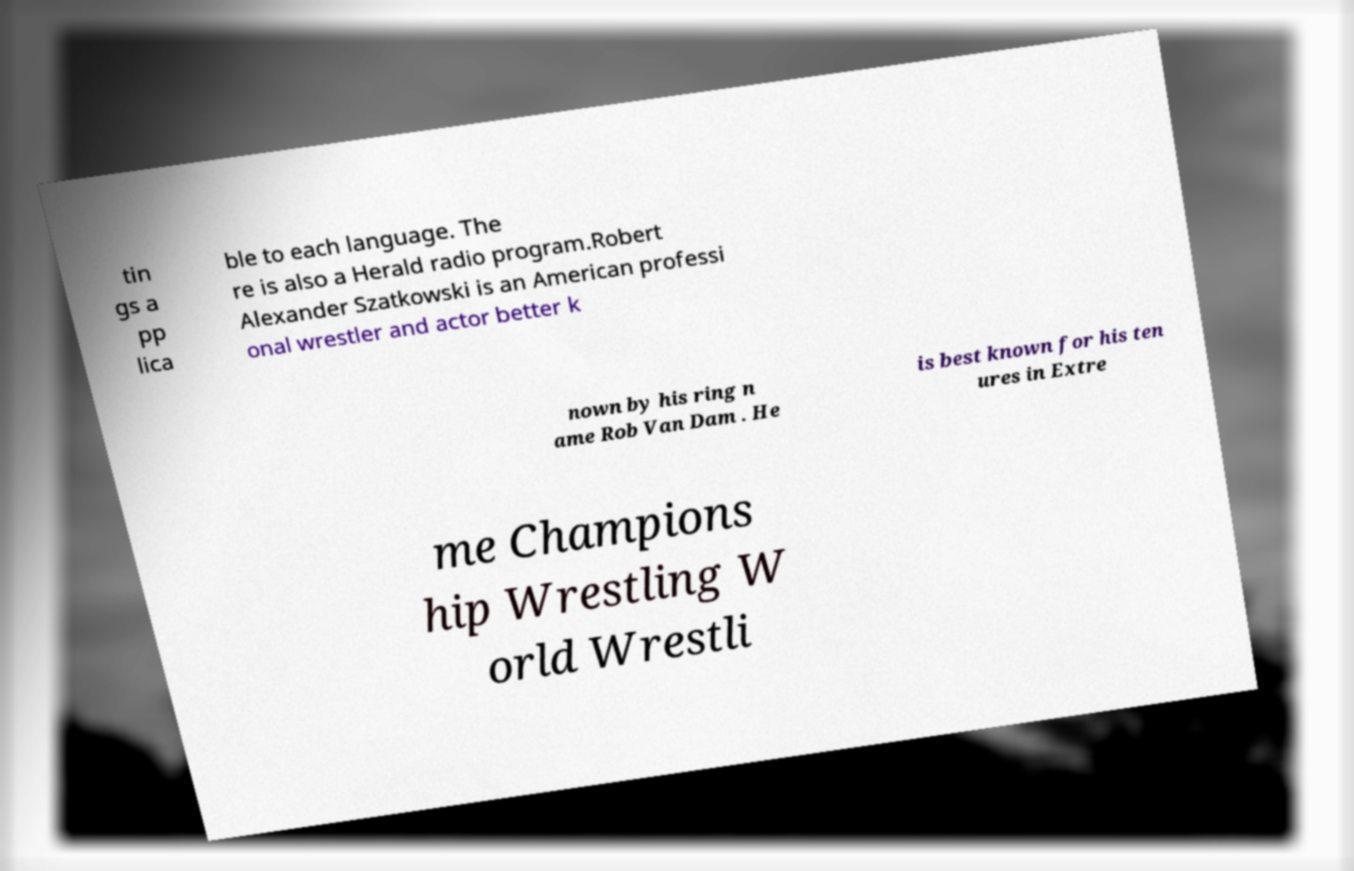Could you assist in decoding the text presented in this image and type it out clearly? tin gs a pp lica ble to each language. The re is also a Herald radio program.Robert Alexander Szatkowski is an American professi onal wrestler and actor better k nown by his ring n ame Rob Van Dam . He is best known for his ten ures in Extre me Champions hip Wrestling W orld Wrestli 